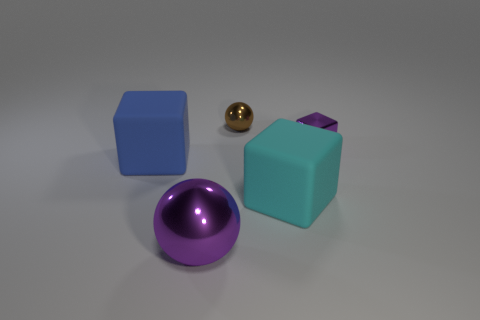Can you describe the positioning of the objects in relation to each other? Certainly! I see a cyan cube on the left, centrally positioned in the image. To its right, there's a small shiny golden sphere, and further to the right is a purple shiny sphere close to the foreground. Another cyan cube, this time with a cut corner, is situated to the right of the purple sphere, slightly in the background. 